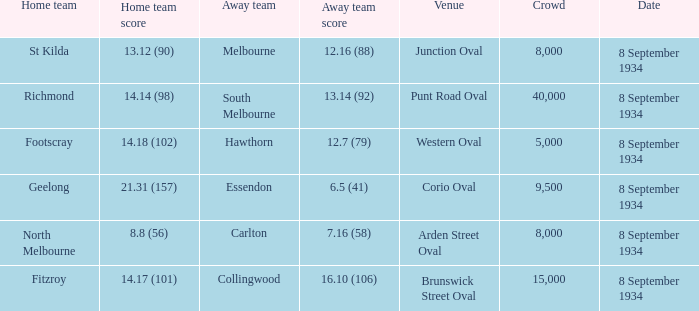When the Home team scored 14.14 (98), what did the Away Team score? 13.14 (92). 